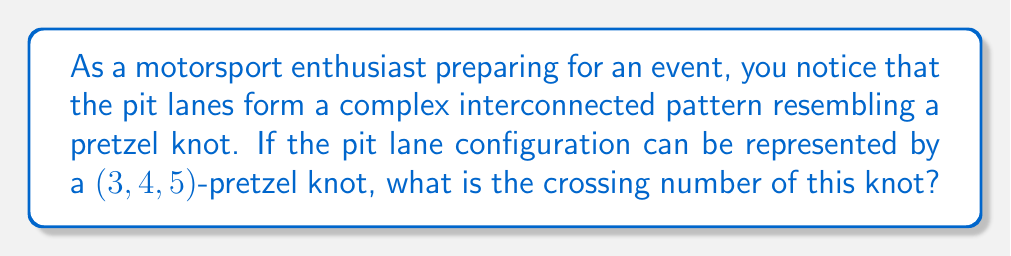Can you answer this question? To determine the crossing number of a $(p,q,r)$-pretzel knot, we follow these steps:

1. Recall the formula for the crossing number of a pretzel knot:
   $$c(K_{p,q,r}) = |p| + |q| + |r|$$
   where $p$, $q$, and $r$ are non-zero integers.

2. In this case, we have a $(3,4,5)$-pretzel knot, so:
   $p = 3$, $q = 4$, and $r = 5$

3. Apply the formula:
   $$c(K_{3,4,5}) = |3| + |4| + |5|$$

4. Calculate the absolute values:
   $$c(K_{3,4,5}) = 3 + 4 + 5$$

5. Sum up the values:
   $$c(K_{3,4,5}) = 12$$

Therefore, the crossing number of the $(3,4,5)$-pretzel knot representing the interconnected pit lanes is 12.
Answer: 12 